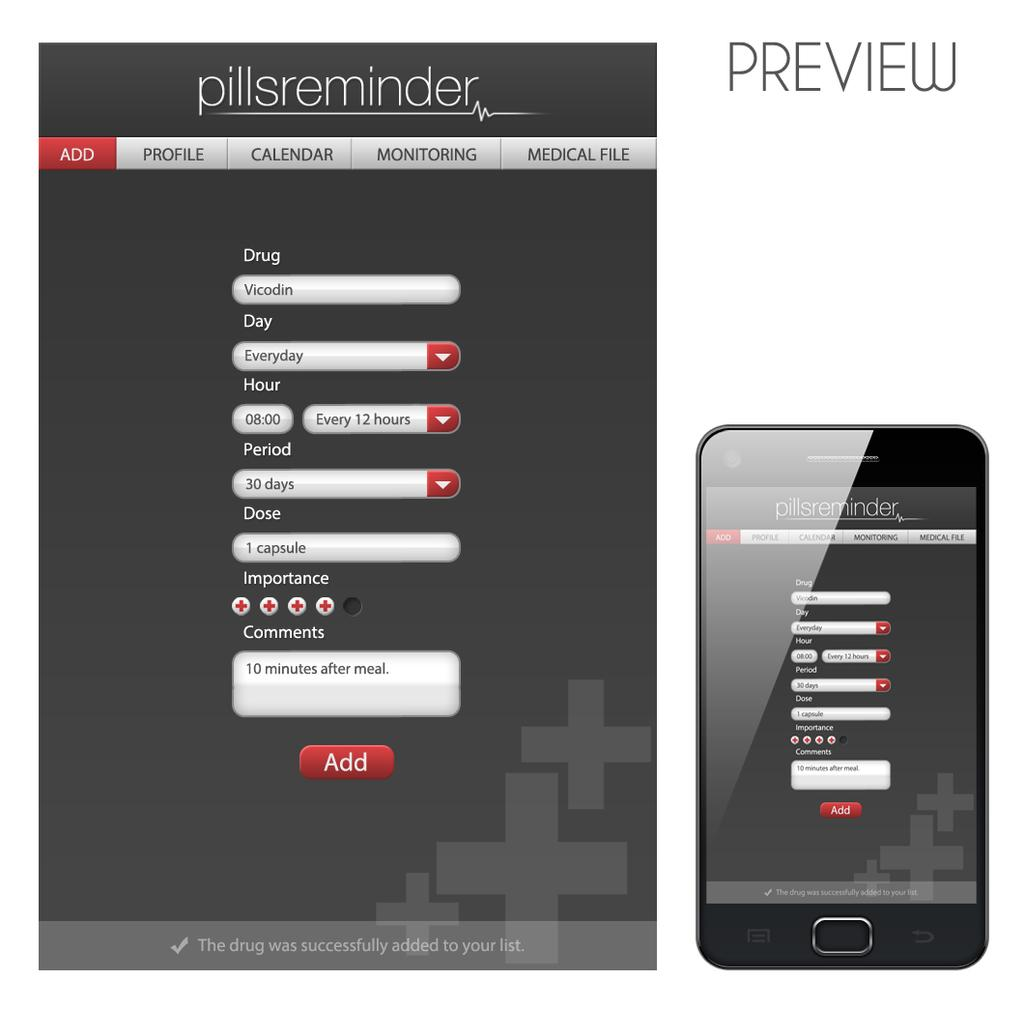Provide a one-sentence caption for the provided image. Two versions of a pillsreminder screen show the add feature. 